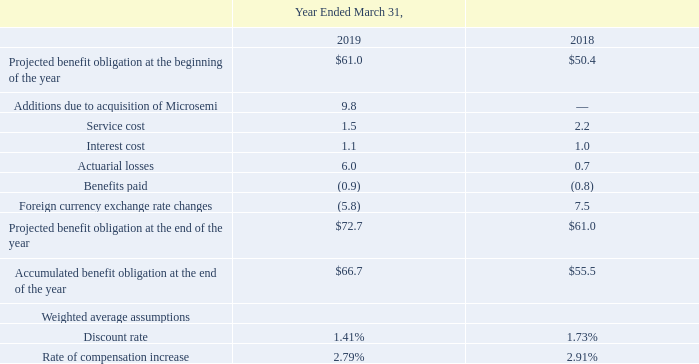The change in projected benefit obligation and the accumulated benefit obligation, were as follows (in millions):
The Company's pension liability represents the present value of estimated future benefits to be paid. The discount rate is based on the quarterly average yield for Euros treasuries with a duration of 30 years, plus a supplement for corporate bonds  consolidated balance sheets, will be recognized as a component of net periodic cost over the average remaining service period.
As the defined benefit plans are unfunded, the liability recognized on the Company's consolidated balance sheet as of March 31, 2019 was $72.7 million of which $1.3 million is included in accrued liabilities and $71.4 million is included in other long-term liabilities. The liability recognized on the Company's consolidated balance sheet as of March 31, 2018 was $61.0 million of which $0.9 million is included in accrued liabilities and $60.1 million is included in other long-term liabilities.
Which years does the table provide information for the change in projected benefit obligation and the accumulated benefit obligation? 2019, 2018. What was the service cost in 2018?
Answer scale should be: million. 2.2. What was the interest cost in 2019?
Answer scale should be: million. 1.1. What was the change in Service cost between 2018 and 2019?
Answer scale should be: million. 1.5-2.2
Answer: -0.7. What was the change in the Discount rate between 2018 and 2019?
Answer scale should be: percent. 1.41-1.73
Answer: -0.32. What was the percentage change in the Projected benefit obligation at the end of the year between 2018 and 2019?
Answer scale should be: percent. (72.7-61.0)/61.0
Answer: 19.18. 